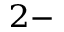<formula> <loc_0><loc_0><loc_500><loc_500>^ { 2 - }</formula> 